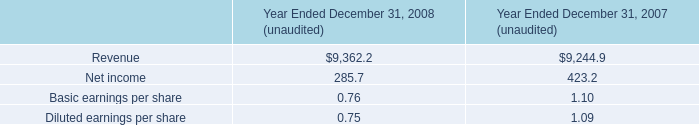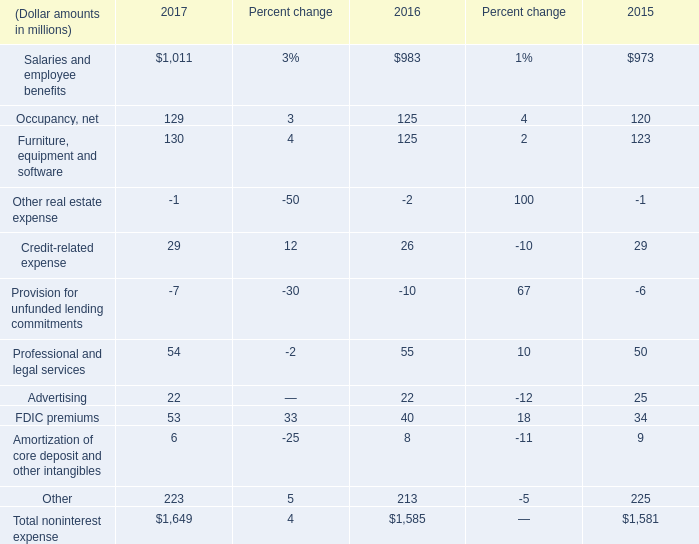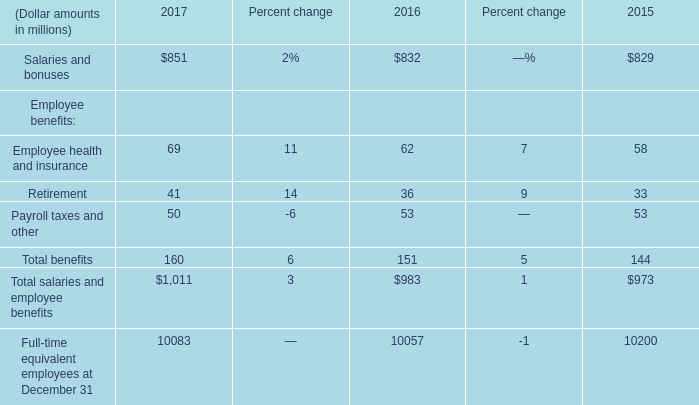what was the percent of the decline in the asset impairment loss for the years ended december 31 , 2009 and 2008 
Computations: ((1.8 - 6.1) - 6.1)
Answer: -10.4. 